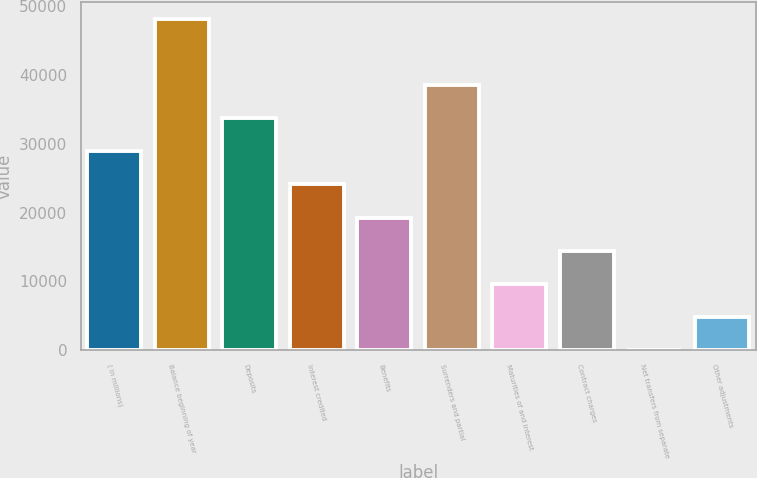Convert chart to OTSL. <chart><loc_0><loc_0><loc_500><loc_500><bar_chart><fcel>( in millions)<fcel>Balance beginning of year<fcel>Deposits<fcel>Interest credited<fcel>Benefits<fcel>Surrenders and partial<fcel>Maturities of and interest<fcel>Contract charges<fcel>Net transfers from separate<fcel>Other adjustments<nl><fcel>28921.8<fcel>48195<fcel>33740.1<fcel>24103.5<fcel>19285.2<fcel>38558.4<fcel>9648.6<fcel>14466.9<fcel>12<fcel>4830.3<nl></chart> 